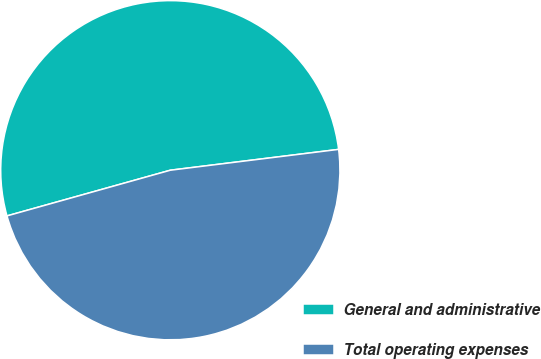<chart> <loc_0><loc_0><loc_500><loc_500><pie_chart><fcel>General and administrative<fcel>Total operating expenses<nl><fcel>52.38%<fcel>47.62%<nl></chart> 